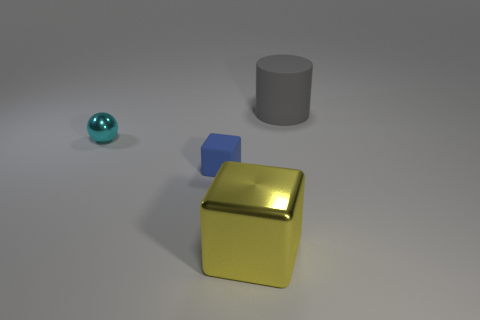Add 4 large cylinders. How many objects exist? 8 Subtract all cylinders. How many objects are left? 3 Add 3 tiny blue things. How many tiny blue things exist? 4 Subtract 0 gray cubes. How many objects are left? 4 Subtract all big brown rubber objects. Subtract all tiny things. How many objects are left? 2 Add 3 big rubber cylinders. How many big rubber cylinders are left? 4 